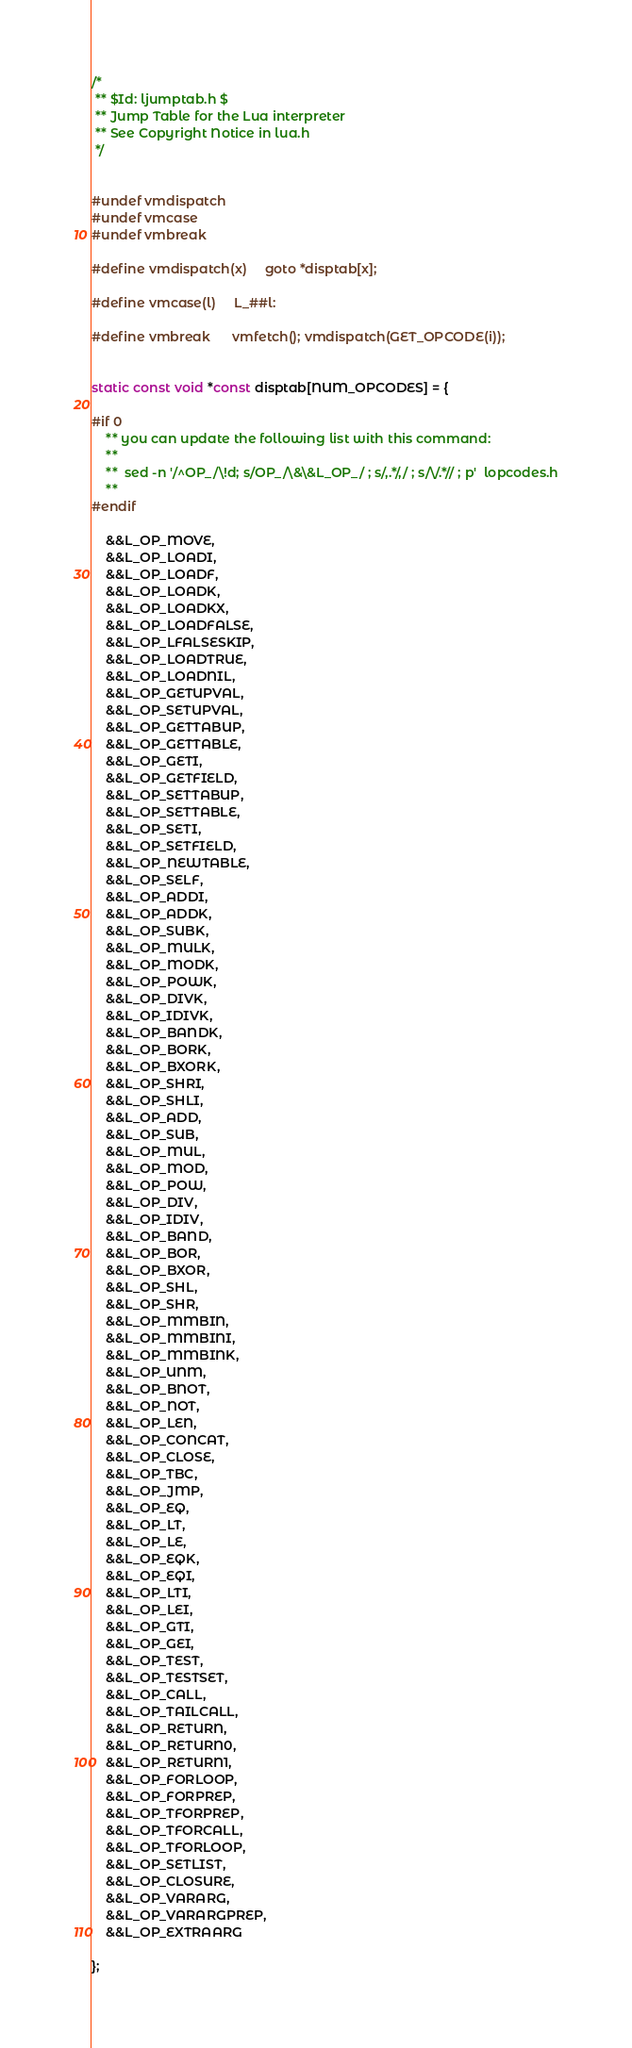<code> <loc_0><loc_0><loc_500><loc_500><_C_>/*
 ** $Id: ljumptab.h $
 ** Jump Table for the Lua interpreter
 ** See Copyright Notice in lua.h
 */


#undef vmdispatch
#undef vmcase
#undef vmbreak

#define vmdispatch(x)     goto *disptab[x];

#define vmcase(l)     L_##l:

#define vmbreak		vmfetch(); vmdispatch(GET_OPCODE(i));


static const void *const disptab[NUM_OPCODES] = {
    
#if 0
    ** you can update the following list with this command:
    **
    **  sed -n '/^OP_/\!d; s/OP_/\&\&L_OP_/ ; s/,.*/,/ ; s/\/.*// ; p'  lopcodes.h
    **
#endif
    
    &&L_OP_MOVE,
    &&L_OP_LOADI,
    &&L_OP_LOADF,
    &&L_OP_LOADK,
    &&L_OP_LOADKX,
    &&L_OP_LOADFALSE,
    &&L_OP_LFALSESKIP,
    &&L_OP_LOADTRUE,
    &&L_OP_LOADNIL,
    &&L_OP_GETUPVAL,
    &&L_OP_SETUPVAL,
    &&L_OP_GETTABUP,
    &&L_OP_GETTABLE,
    &&L_OP_GETI,
    &&L_OP_GETFIELD,
    &&L_OP_SETTABUP,
    &&L_OP_SETTABLE,
    &&L_OP_SETI,
    &&L_OP_SETFIELD,
    &&L_OP_NEWTABLE,
    &&L_OP_SELF,
    &&L_OP_ADDI,
    &&L_OP_ADDK,
    &&L_OP_SUBK,
    &&L_OP_MULK,
    &&L_OP_MODK,
    &&L_OP_POWK,
    &&L_OP_DIVK,
    &&L_OP_IDIVK,
    &&L_OP_BANDK,
    &&L_OP_BORK,
    &&L_OP_BXORK,
    &&L_OP_SHRI,
    &&L_OP_SHLI,
    &&L_OP_ADD,
    &&L_OP_SUB,
    &&L_OP_MUL,
    &&L_OP_MOD,
    &&L_OP_POW,
    &&L_OP_DIV,
    &&L_OP_IDIV,
    &&L_OP_BAND,
    &&L_OP_BOR,
    &&L_OP_BXOR,
    &&L_OP_SHL,
    &&L_OP_SHR,
    &&L_OP_MMBIN,
    &&L_OP_MMBINI,
    &&L_OP_MMBINK,
    &&L_OP_UNM,
    &&L_OP_BNOT,
    &&L_OP_NOT,
    &&L_OP_LEN,
    &&L_OP_CONCAT,
    &&L_OP_CLOSE,
    &&L_OP_TBC,
    &&L_OP_JMP,
    &&L_OP_EQ,
    &&L_OP_LT,
    &&L_OP_LE,
    &&L_OP_EQK,
    &&L_OP_EQI,
    &&L_OP_LTI,
    &&L_OP_LEI,
    &&L_OP_GTI,
    &&L_OP_GEI,
    &&L_OP_TEST,
    &&L_OP_TESTSET,
    &&L_OP_CALL,
    &&L_OP_TAILCALL,
    &&L_OP_RETURN,
    &&L_OP_RETURN0,
    &&L_OP_RETURN1,
    &&L_OP_FORLOOP,
    &&L_OP_FORPREP,
    &&L_OP_TFORPREP,
    &&L_OP_TFORCALL,
    &&L_OP_TFORLOOP,
    &&L_OP_SETLIST,
    &&L_OP_CLOSURE,
    &&L_OP_VARARG,
    &&L_OP_VARARGPREP,
    &&L_OP_EXTRAARG
    
};
</code> 